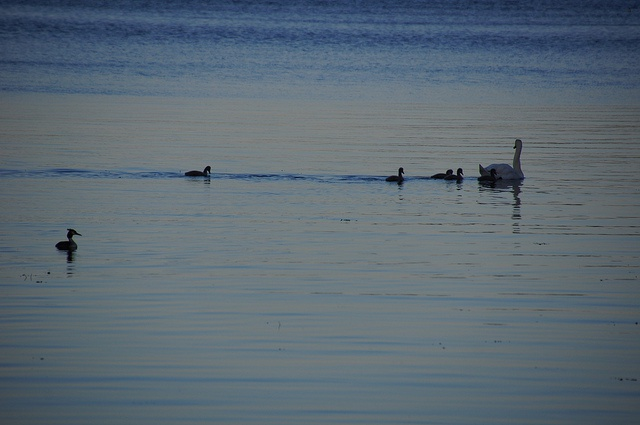Describe the objects in this image and their specific colors. I can see bird in navy, black, darkblue, and gray tones, bird in navy, black, gray, and darkgreen tones, bird in navy, black, gray, and blue tones, bird in navy, black, and gray tones, and bird in navy, black, and gray tones in this image. 